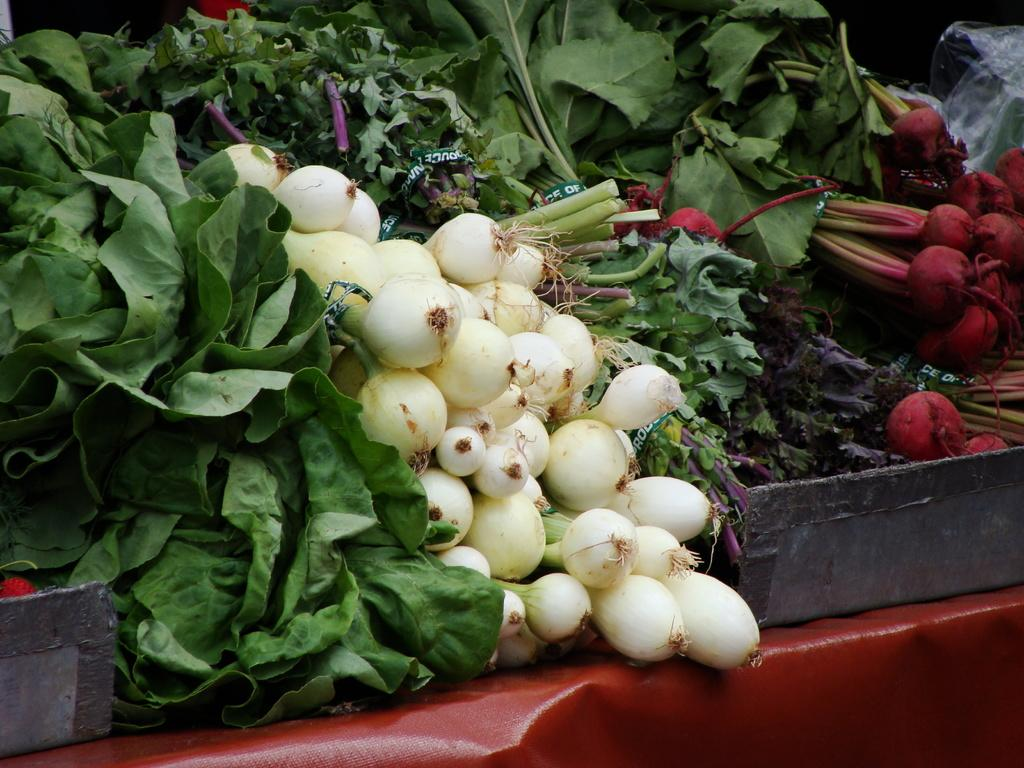What type of food is present on the trays in the image? There are vegetables on trays in the image. Can you describe any other objects or materials in the image? There is a sheet in the image. What is the writer doing with the vegetables in the image? There is no writer present in the image, and therefore no action involving the vegetables can be observed. 